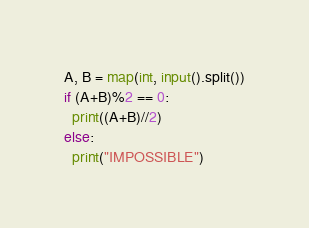<code> <loc_0><loc_0><loc_500><loc_500><_Python_>A, B = map(int, input().split())
if (A+B)%2 == 0:
  print((A+B)//2)
else:
  print("IMPOSSIBLE")</code> 